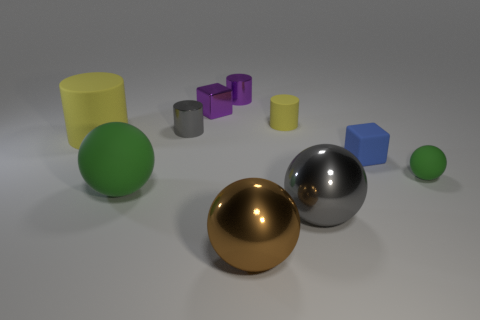Do the rubber ball that is to the right of the tiny gray shiny thing and the large rubber sphere have the same color?
Make the answer very short. Yes. What is the size of the other metal object that is the same shape as the small gray thing?
Your answer should be very brief. Small. There is a rubber cylinder in front of the yellow rubber object that is right of the large brown thing; is there a purple metallic cylinder right of it?
Give a very brief answer. Yes. There is a block on the left side of the big brown object; what is it made of?
Provide a short and direct response. Metal. How many small objects are yellow matte cylinders or green rubber objects?
Offer a terse response. 2. There is a green matte object on the right side of the blue cube; is its size the same as the large brown thing?
Provide a short and direct response. No. How many other things are the same color as the tiny ball?
Keep it short and to the point. 1. What material is the big green object?
Give a very brief answer. Rubber. What is the sphere that is both right of the large green rubber sphere and on the left side of the gray shiny ball made of?
Give a very brief answer. Metal. What number of things are big spheres to the right of the purple shiny block or yellow things?
Offer a very short reply. 4. 